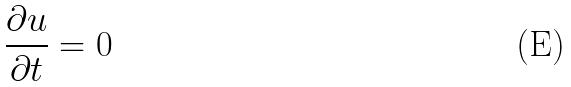<formula> <loc_0><loc_0><loc_500><loc_500>\frac { \partial u } { \partial t } = 0</formula> 